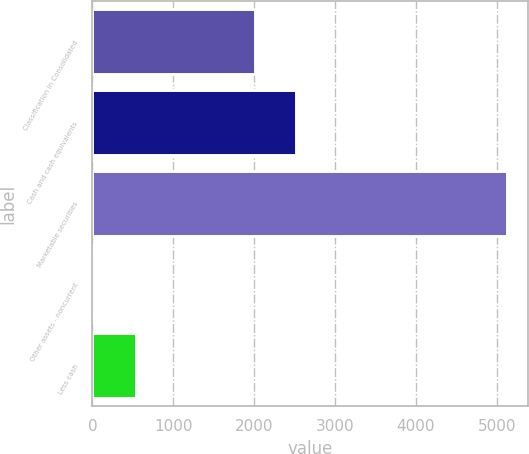<chart> <loc_0><loc_0><loc_500><loc_500><bar_chart><fcel>Classification in Consolidated<fcel>Cash and cash equivalents<fcel>Marketable securities<fcel>Other assets - noncurrent<fcel>Less cash<nl><fcel>2007<fcel>2516.7<fcel>5127<fcel>30<fcel>539.7<nl></chart> 